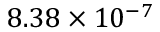<formula> <loc_0><loc_0><loc_500><loc_500>8 . 3 8 \times 1 0 ^ { - 7 }</formula> 